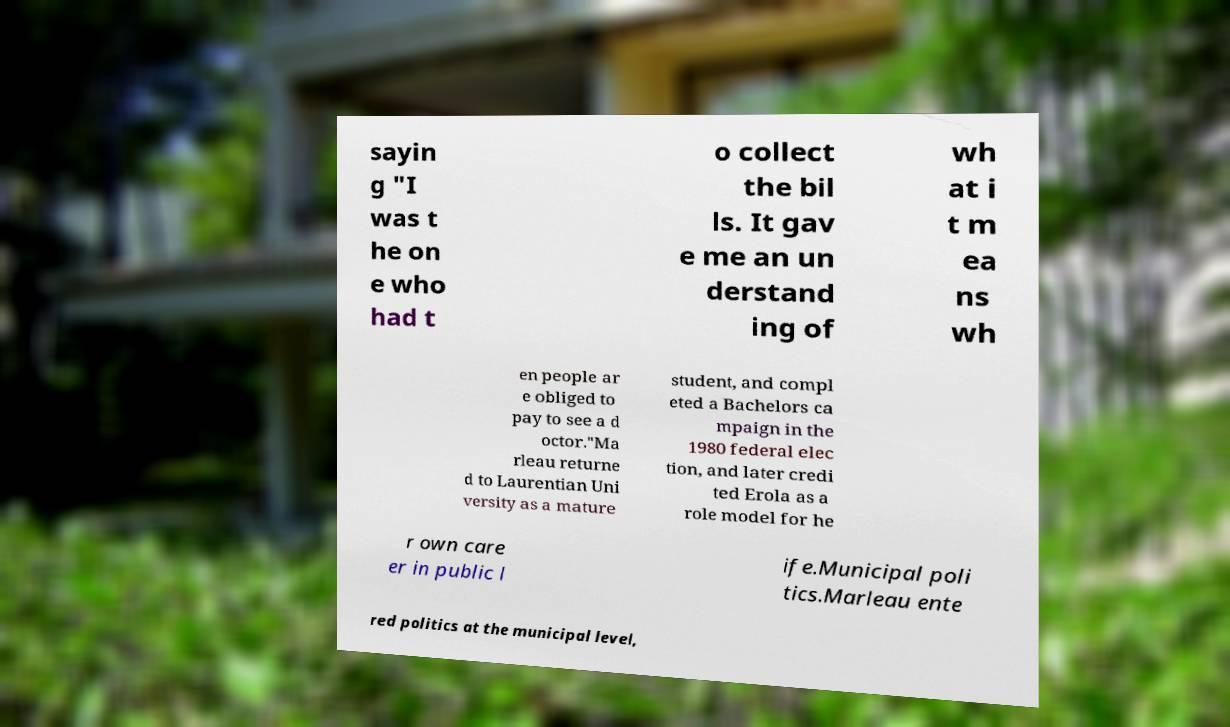Please identify and transcribe the text found in this image. sayin g "I was t he on e who had t o collect the bil ls. It gav e me an un derstand ing of wh at i t m ea ns wh en people ar e obliged to pay to see a d octor."Ma rleau returne d to Laurentian Uni versity as a mature student, and compl eted a Bachelors ca mpaign in the 1980 federal elec tion, and later credi ted Erola as a role model for he r own care er in public l ife.Municipal poli tics.Marleau ente red politics at the municipal level, 